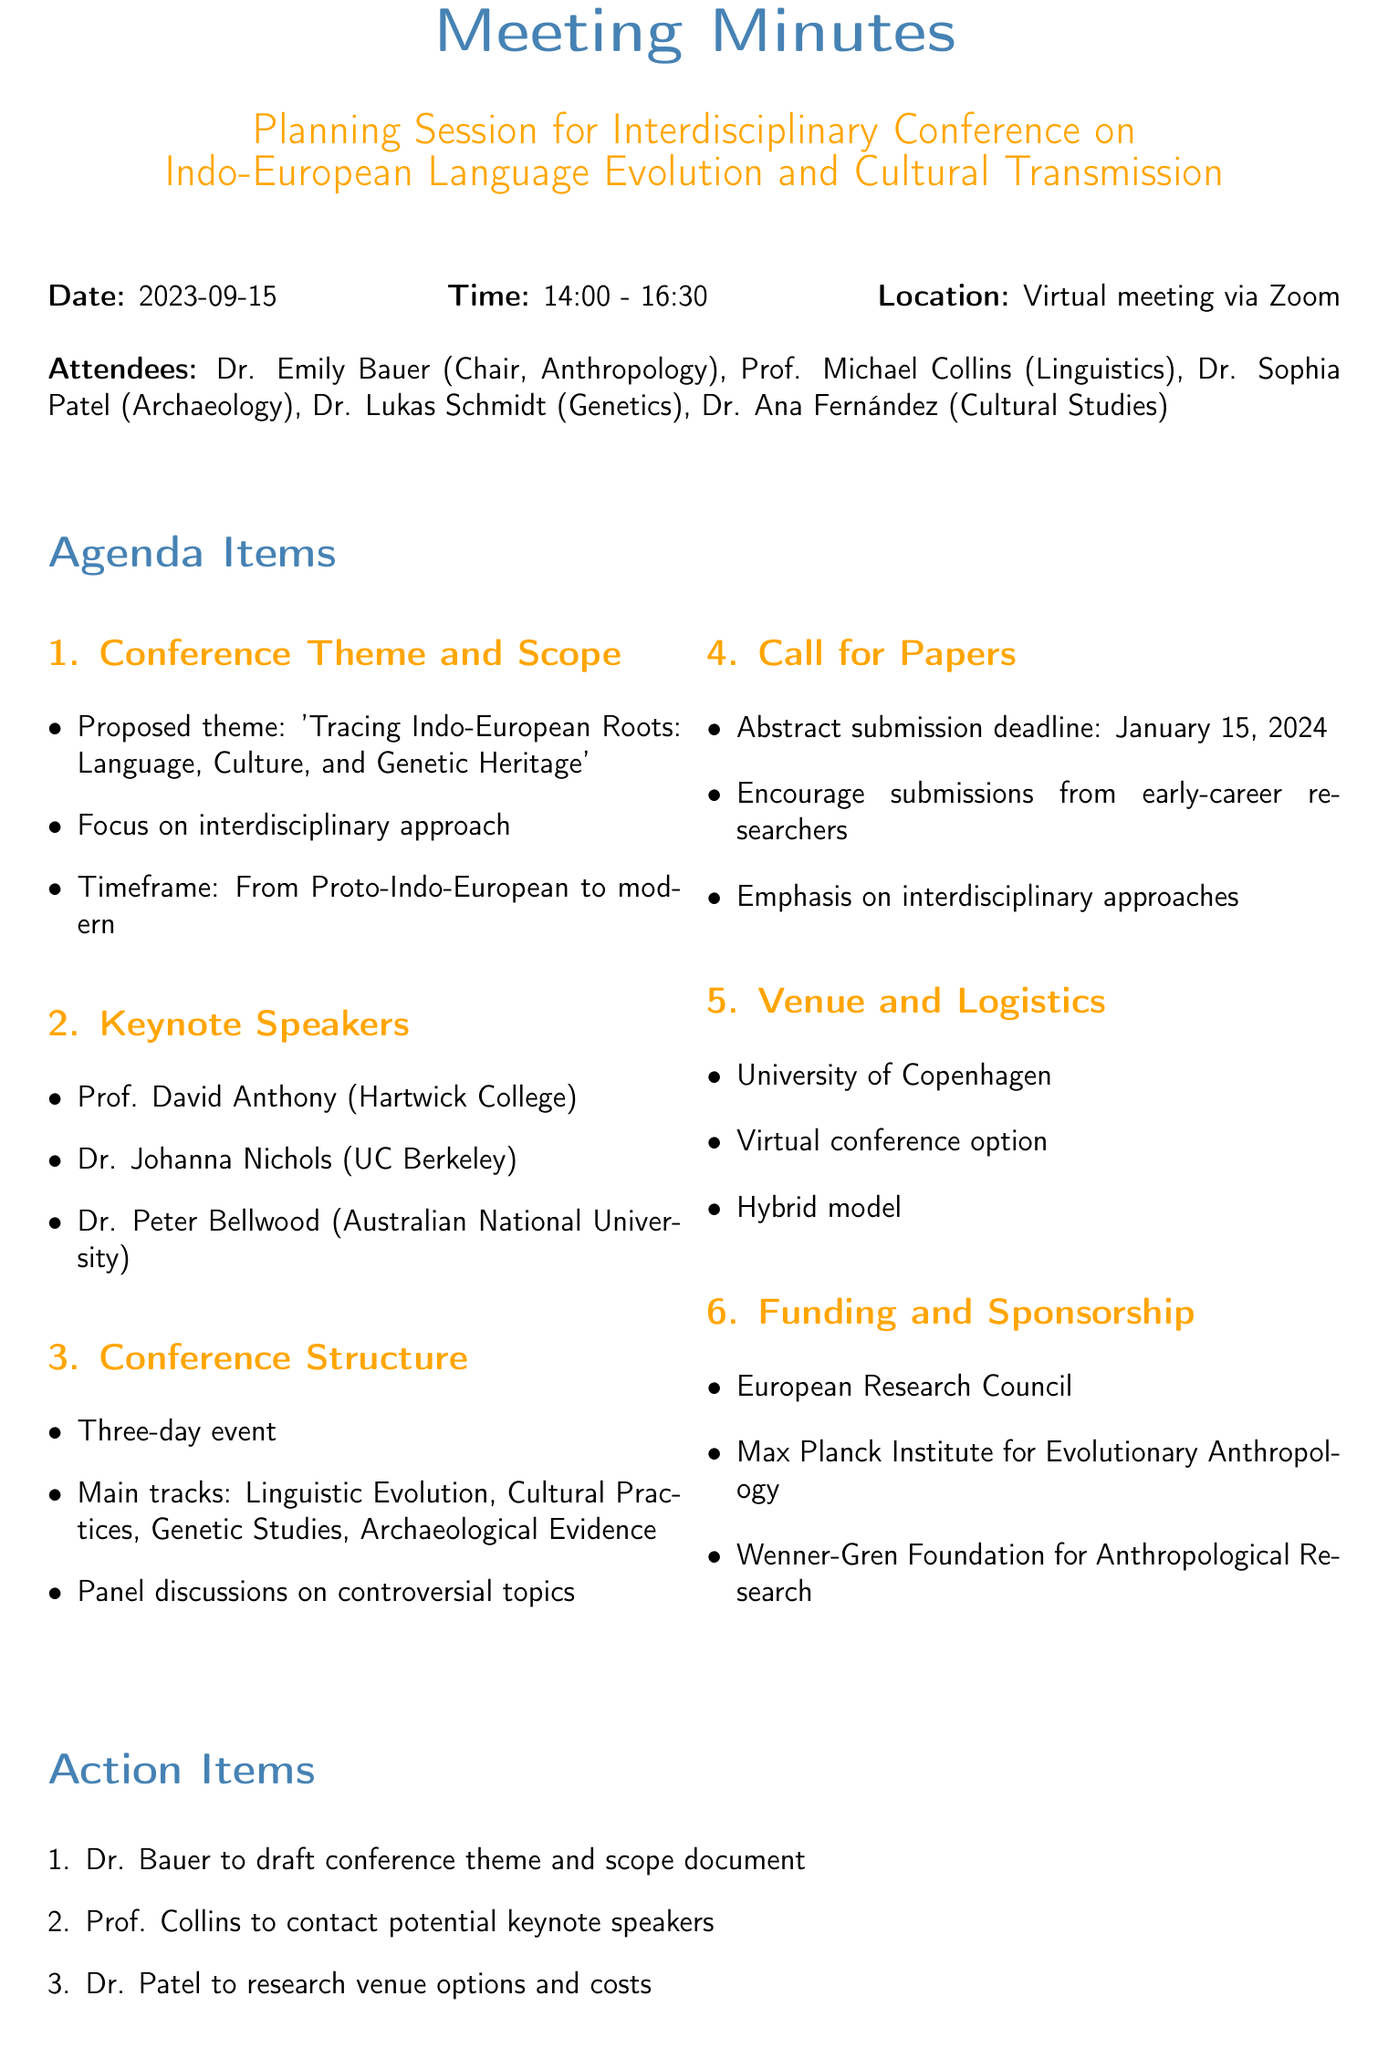what is the proposed theme of the conference? The proposed theme is stated in the document under the Conference Theme and Scope section.
Answer: 'Tracing Indo-European Roots: Language, Culture, and Genetic Heritage' who is the chair of the meeting? The chair is mentioned at the beginning of the document in the list of attendees.
Answer: Dr. Emily Bauer when is the abstract submission deadline? The deadline for abstract submission is clearly specified in the Call for Papers section of the document.
Answer: January 15, 2024 where is one potential venue for the conference? The potential venue options are listed under the Venue and Logistics section of the document.
Answer: University of Copenhagen how long will the conference last? The duration of the conference is outlined in the Conference Structure section.
Answer: Three-day event what are the main tracks of the conference? The main tracks are listed in the Conference Structure section, combining various fields of study.
Answer: Linguistic Evolution, Cultural Practices, Genetic Studies, Archaeological Evidence who is responsible for drafting the call for papers? The action items specify who is responsible for various tasks related to the conference planning.
Answer: Dr. Fernández which organization is a potential source of funding? The potential sources of funding are mentioned under the Funding and Sponsorship section.
Answer: European Research Council 